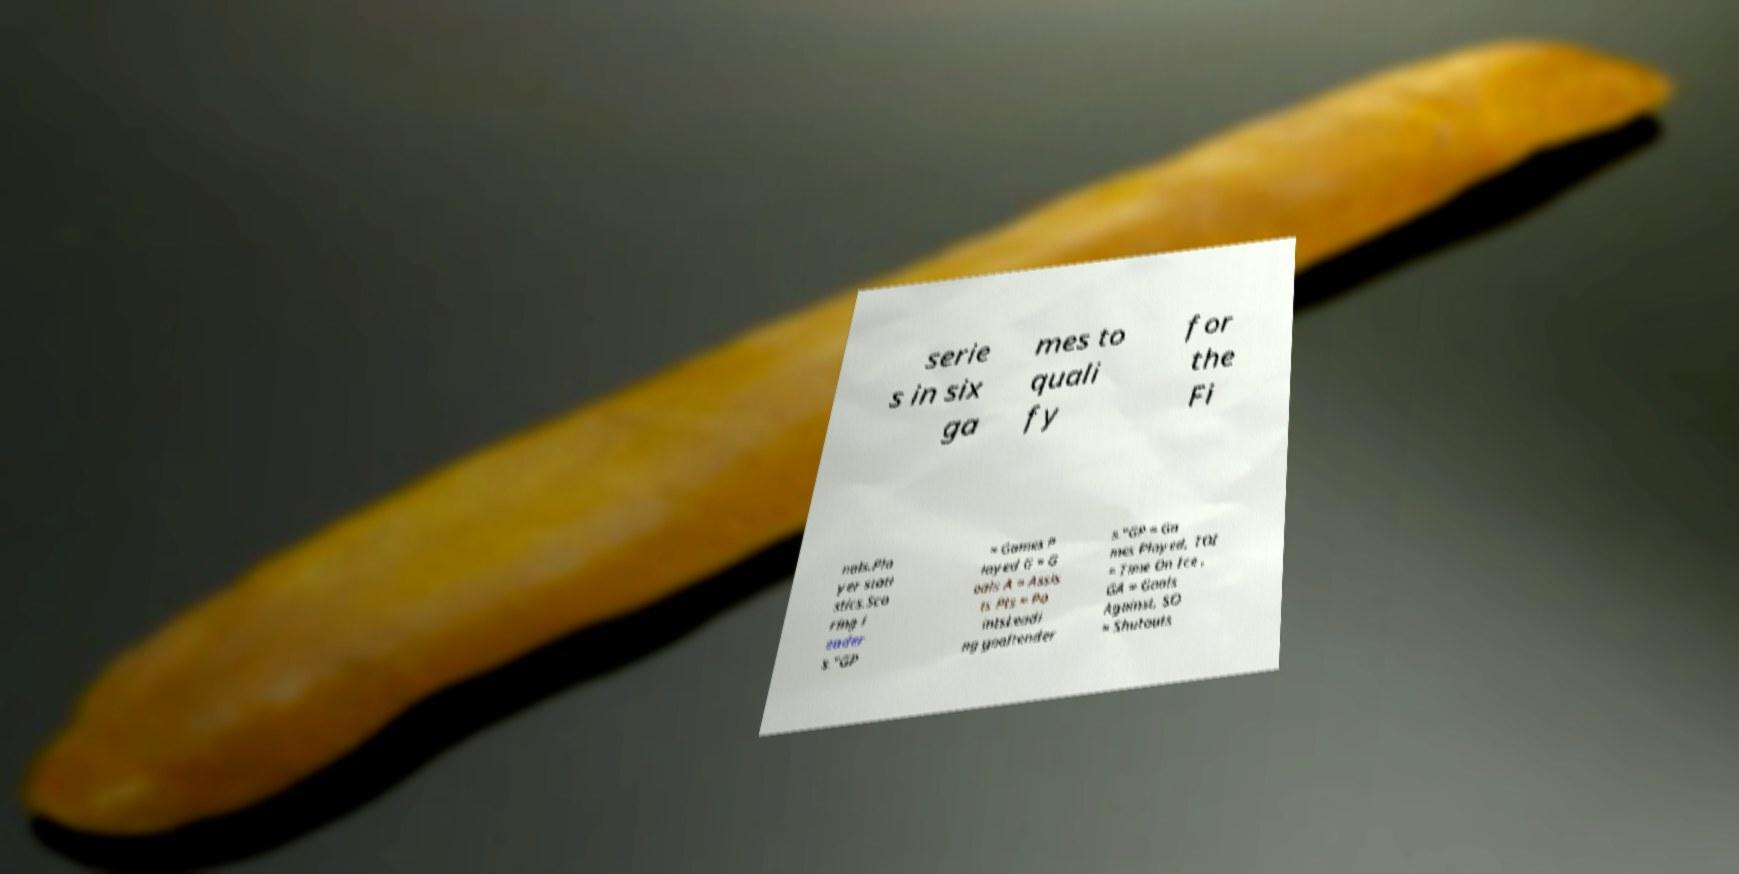There's text embedded in this image that I need extracted. Can you transcribe it verbatim? serie s in six ga mes to quali fy for the Fi nals.Pla yer stati stics.Sco ring l eader s."GP = Games P layed G = G oals A = Assis ts Pts = Po intsLeadi ng goaltender s."GP = Ga mes Played, TOI = Time On Ice , GA = Goals Against, SO = Shutouts 